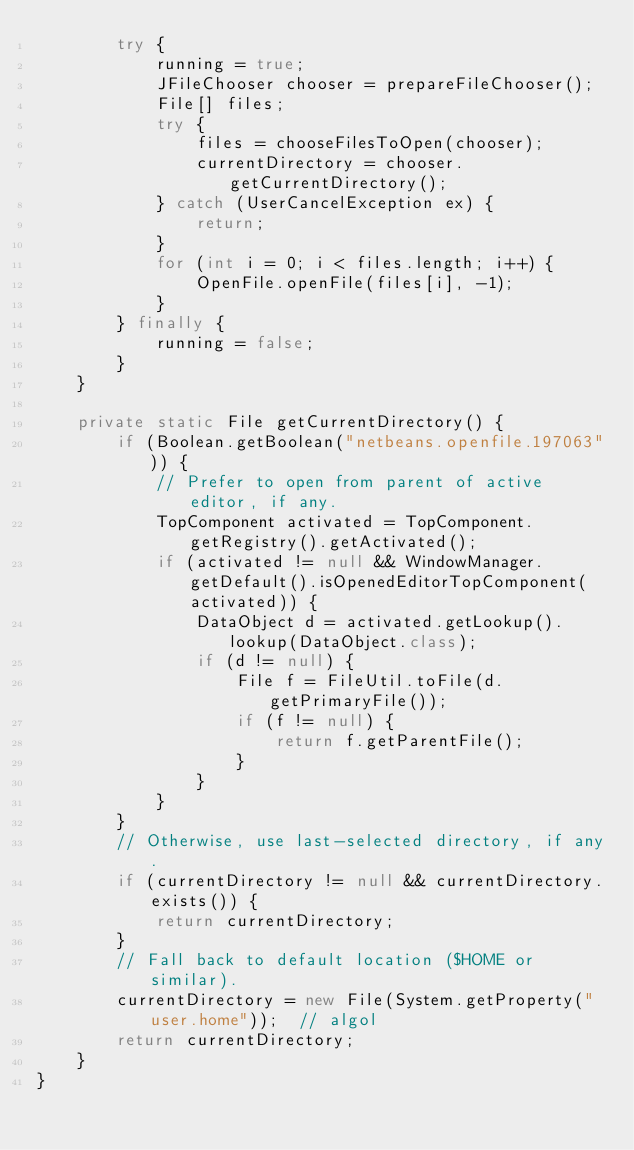Convert code to text. <code><loc_0><loc_0><loc_500><loc_500><_Java_>        try {
            running = true;
            JFileChooser chooser = prepareFileChooser();
            File[] files;
            try {
                files = chooseFilesToOpen(chooser);
                currentDirectory = chooser.getCurrentDirectory();
            } catch (UserCancelException ex) {
                return;
            }
            for (int i = 0; i < files.length; i++) {
                OpenFile.openFile(files[i], -1);
            }
        } finally {
            running = false;
        }
    }

    private static File getCurrentDirectory() {
        if (Boolean.getBoolean("netbeans.openfile.197063")) {
            // Prefer to open from parent of active editor, if any.
            TopComponent activated = TopComponent.getRegistry().getActivated();
            if (activated != null && WindowManager.getDefault().isOpenedEditorTopComponent(activated)) {
                DataObject d = activated.getLookup().lookup(DataObject.class);
                if (d != null) {
                    File f = FileUtil.toFile(d.getPrimaryFile());
                    if (f != null) {
                        return f.getParentFile();
                    }
                }
            }
        }
        // Otherwise, use last-selected directory, if any.
        if (currentDirectory != null && currentDirectory.exists()) {
            return currentDirectory;
        }
        // Fall back to default location ($HOME or similar).
        currentDirectory = new File(System.getProperty("user.home"));  // algol
        return currentDirectory;
    }
}
</code> 